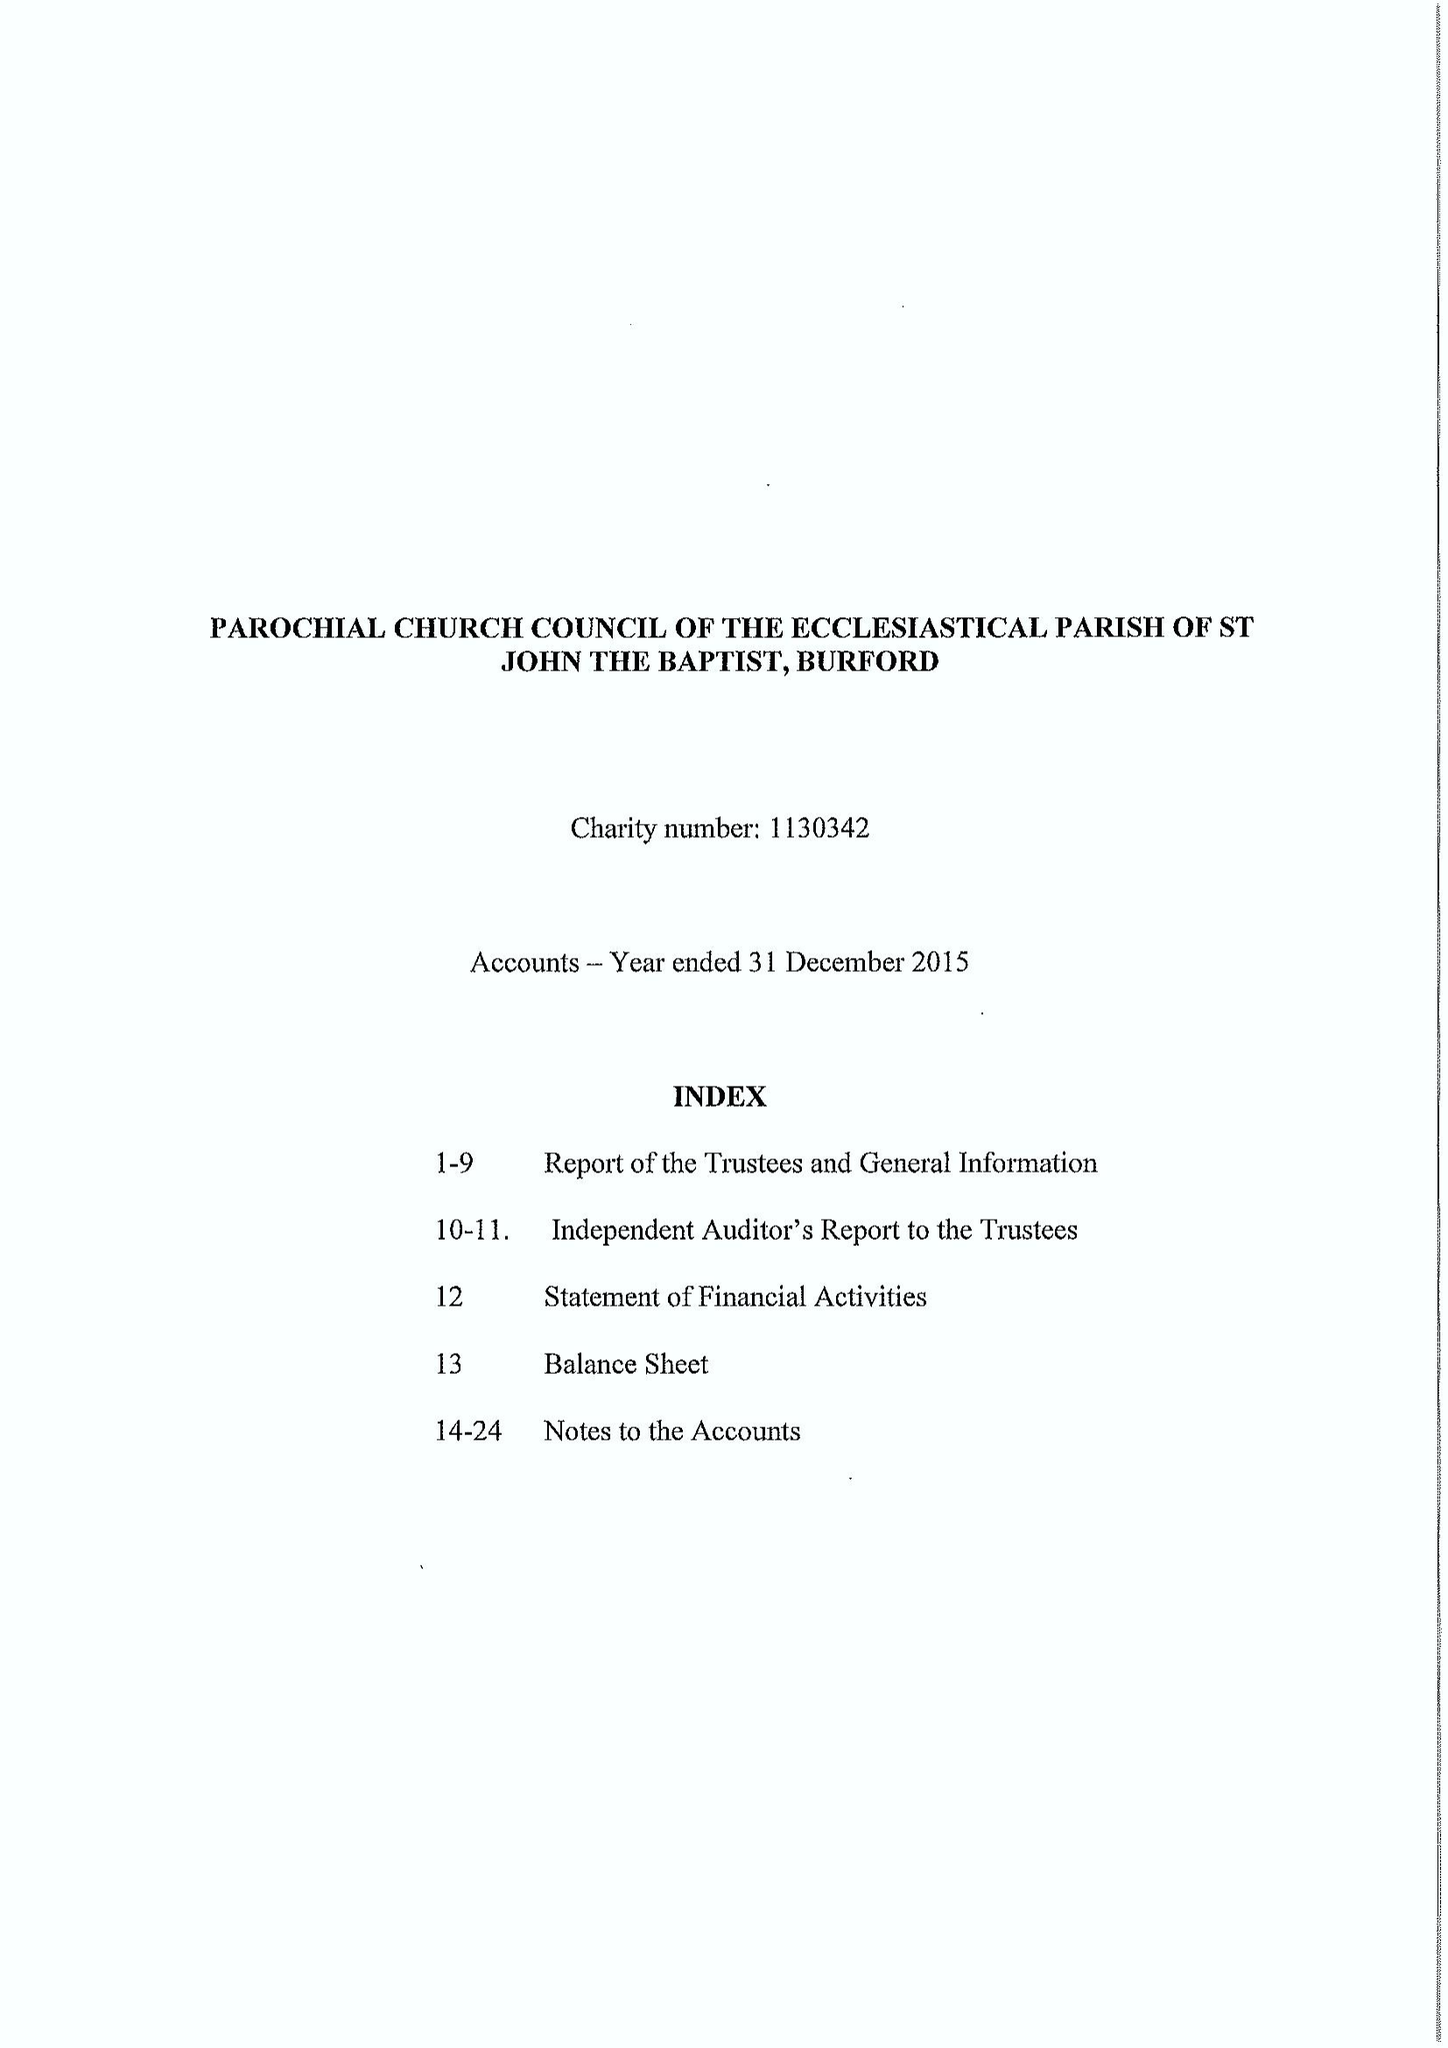What is the value for the report_date?
Answer the question using a single word or phrase. 2015-12-31 